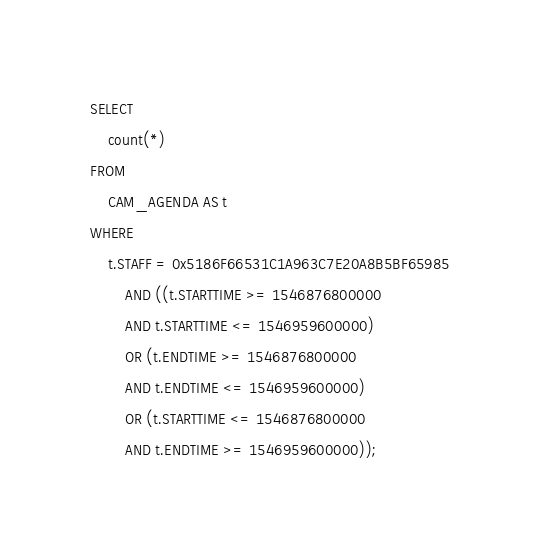<code> <loc_0><loc_0><loc_500><loc_500><_SQL_>SELECT 
    count(*)
FROM
    CAM_AGENDA AS t  
WHERE
    t.STAFF = 0x5186F66531C1A963C7E20A8B5BF65985
        AND ((t.STARTTIME >= 1546876800000
        AND t.STARTTIME <= 1546959600000)
        OR (t.ENDTIME >= 1546876800000
        AND t.ENDTIME <= 1546959600000)
        OR (t.STARTTIME <= 1546876800000
        AND t.ENDTIME >= 1546959600000));
</code> 